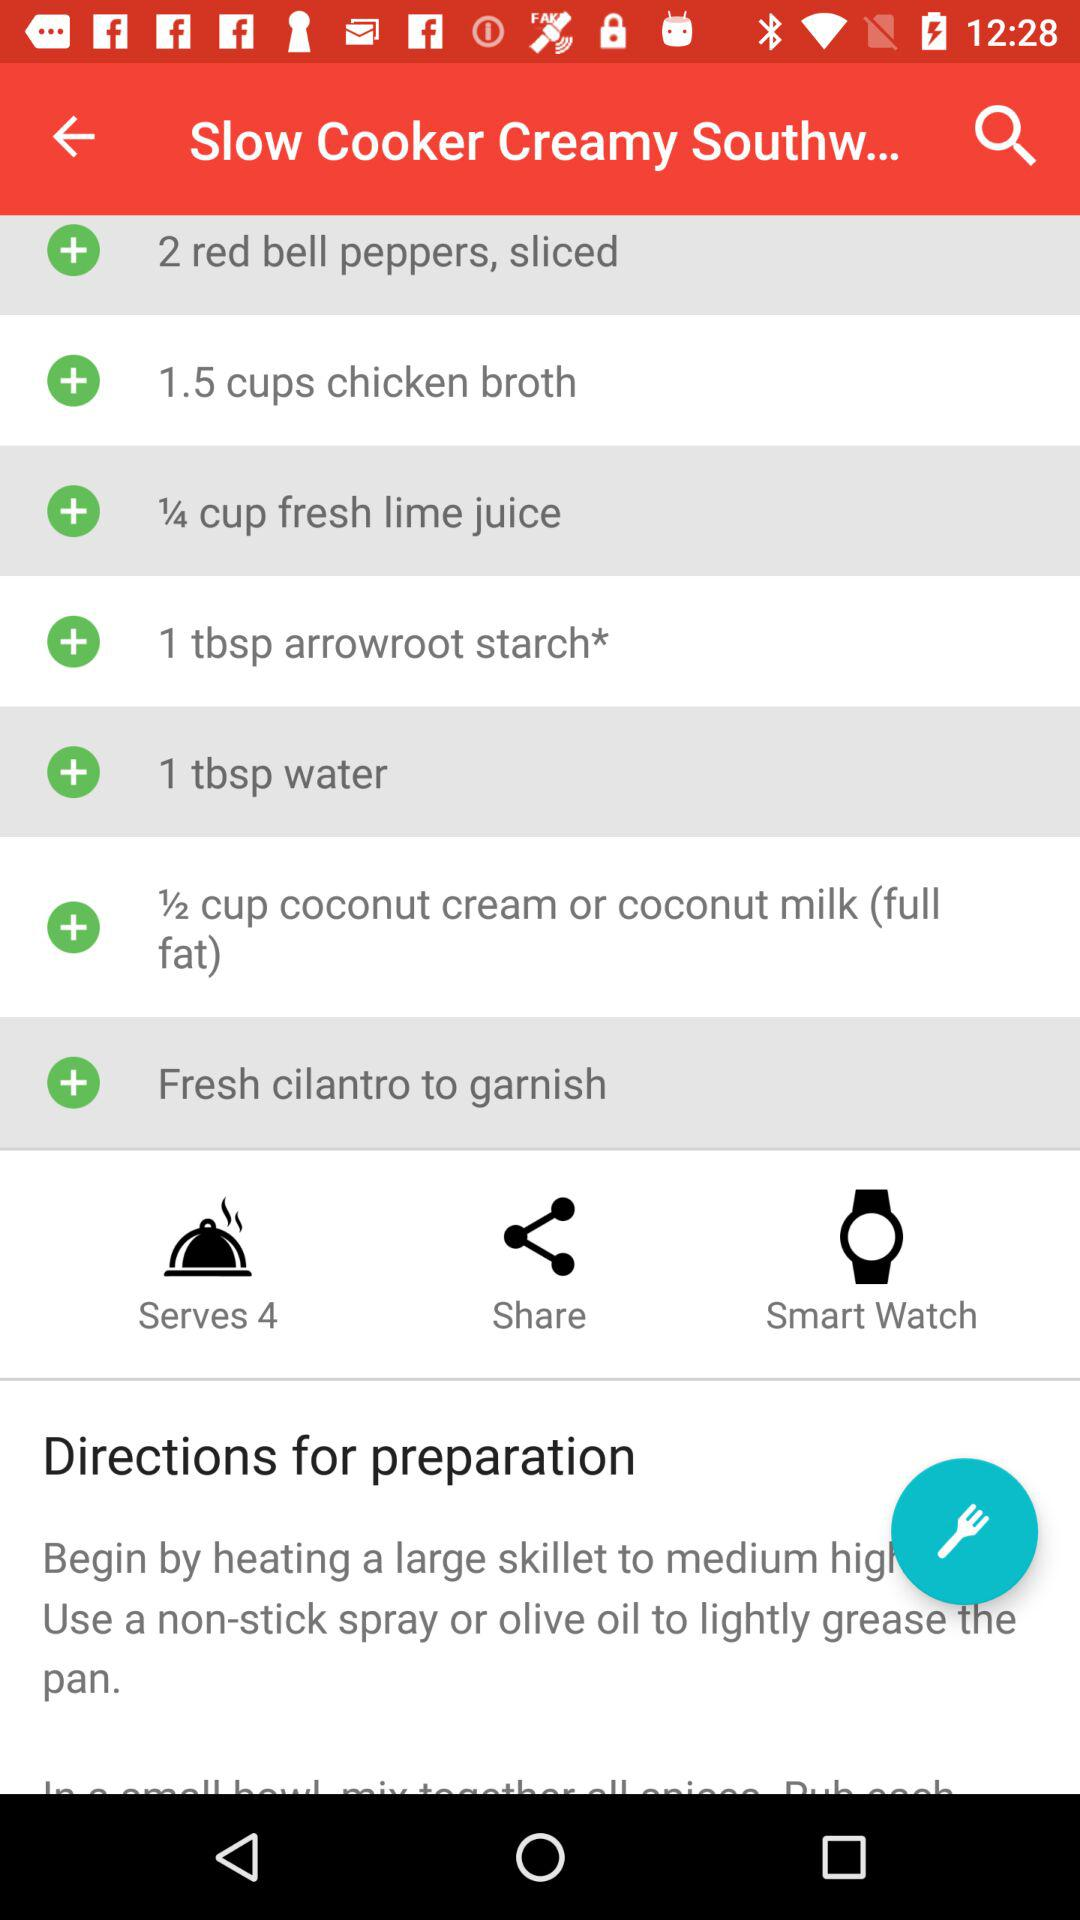How much quantity of "chicken broth" is required? The required quantity of "chicken broth" is 1.5 cups. 